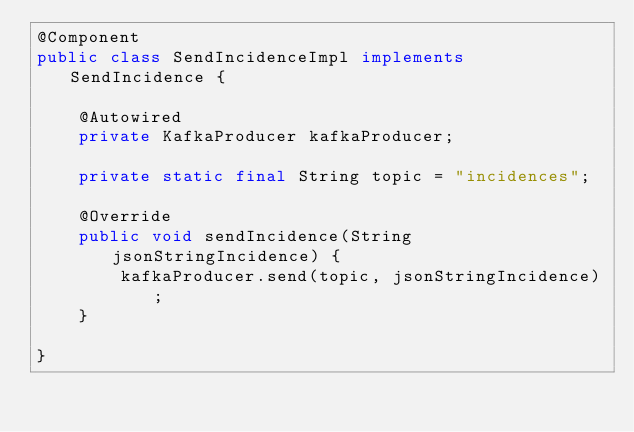Convert code to text. <code><loc_0><loc_0><loc_500><loc_500><_Java_>@Component
public class SendIncidenceImpl implements SendIncidence {

	@Autowired
	private KafkaProducer kafkaProducer;
	
	private static final String topic = "incidences";
	
	@Override
	public void sendIncidence(String jsonStringIncidence) {
		kafkaProducer.send(topic, jsonStringIncidence);
	}

}
</code> 